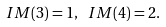Convert formula to latex. <formula><loc_0><loc_0><loc_500><loc_500>I M ( 3 ) = 1 , \ I M ( 4 ) = 2 .</formula> 